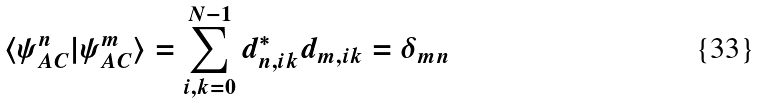<formula> <loc_0><loc_0><loc_500><loc_500>\langle \psi ^ { n } _ { A C } | \psi ^ { m } _ { A C } \rangle = \sum _ { i , k = 0 } ^ { N - 1 } d ^ { * } _ { n , i k } d _ { m , i k } = \delta _ { m n }</formula> 